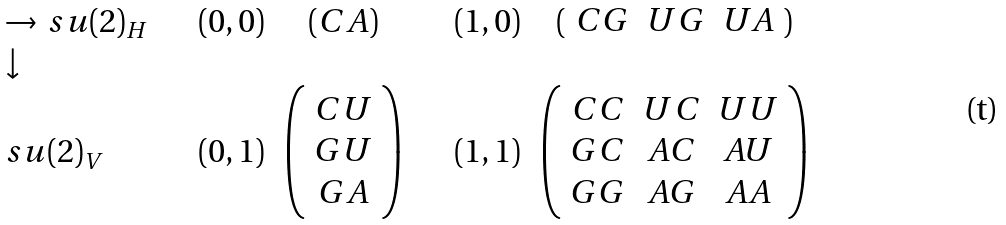Convert formula to latex. <formula><loc_0><loc_0><loc_500><loc_500>\begin{array} { l c c c c } \to \, s u ( 2 ) _ { H } \quad & ( 0 , 0 ) & ( C A ) & \quad ( 1 , 0 ) & ( \begin{array} { c c c } C G & U G & U A \\ \end{array} ) \\ \downarrow \\ s u ( 2 ) _ { V } & ( 0 , 1 ) & \left ( \begin{array} { c } C U \\ G U \\ G A \\ \end{array} \right ) & \quad ( 1 , 1 ) & \left ( \begin{array} { c c c } C C & U C & U U \\ G C & A C & A U \\ G G & A G & A A \\ \end{array} \right ) \end{array}</formula> 